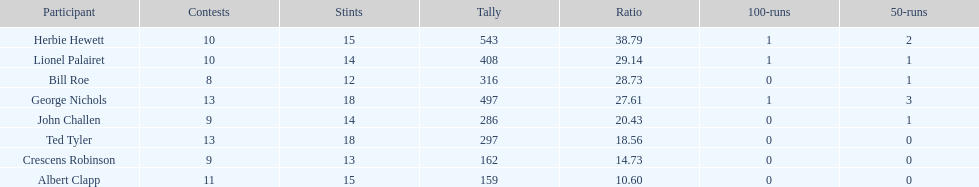How many runs did ted tyler have? 297. 